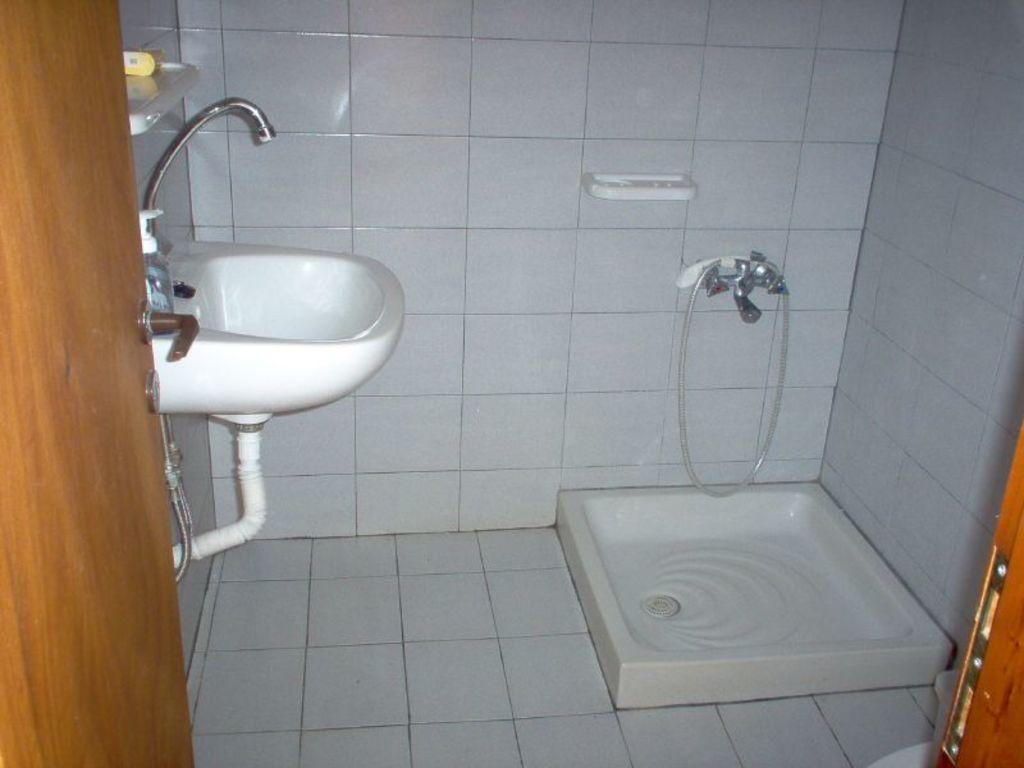Please provide a concise description of this image. This image is taken in the bathroom and here we can see a bottle on the sink and on the right, there is a tap and in the background, there is a wall and we can see door. 